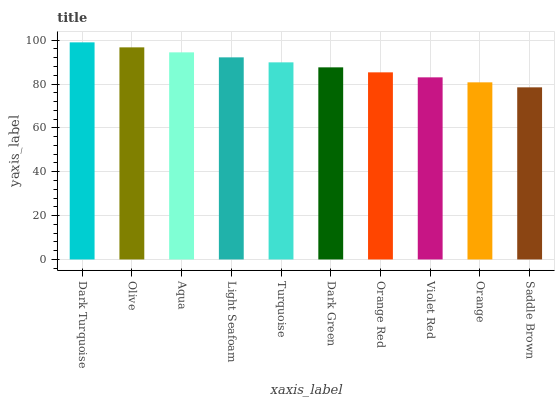Is Olive the minimum?
Answer yes or no. No. Is Olive the maximum?
Answer yes or no. No. Is Dark Turquoise greater than Olive?
Answer yes or no. Yes. Is Olive less than Dark Turquoise?
Answer yes or no. Yes. Is Olive greater than Dark Turquoise?
Answer yes or no. No. Is Dark Turquoise less than Olive?
Answer yes or no. No. Is Turquoise the high median?
Answer yes or no. Yes. Is Dark Green the low median?
Answer yes or no. Yes. Is Olive the high median?
Answer yes or no. No. Is Aqua the low median?
Answer yes or no. No. 